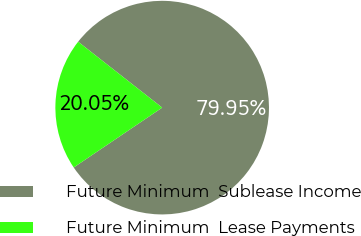Convert chart to OTSL. <chart><loc_0><loc_0><loc_500><loc_500><pie_chart><fcel>Future Minimum  Sublease Income<fcel>Future Minimum  Lease Payments<nl><fcel>79.95%<fcel>20.05%<nl></chart> 